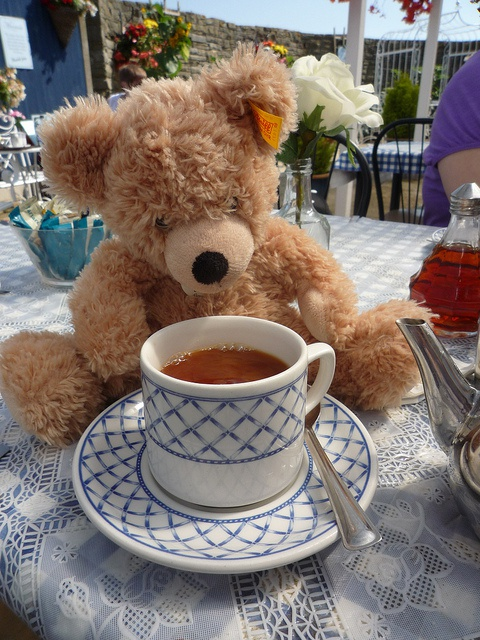Describe the objects in this image and their specific colors. I can see teddy bear in darkblue, gray, brown, maroon, and tan tones, dining table in darkblue, gray, darkgray, and lightgray tones, cup in darkblue, darkgray, gray, and maroon tones, people in darkblue, purple, gray, navy, and black tones, and bottle in darkblue, maroon, darkgray, and gray tones in this image. 